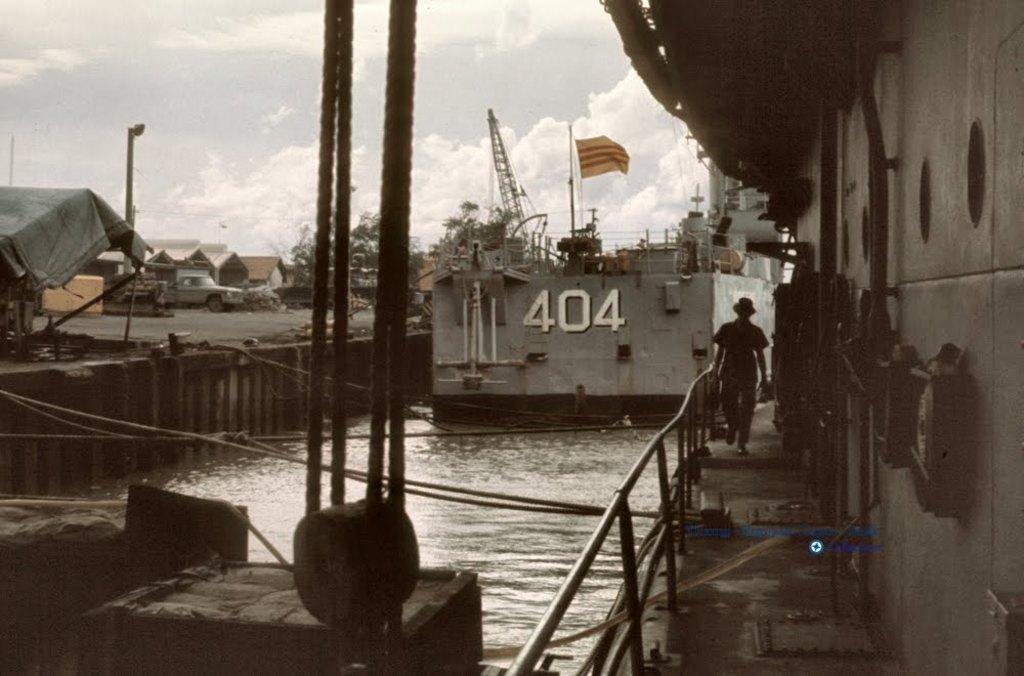What is the primary element visible in the image? There is water in the image. Can you describe the person in the image? There is a person in the image. What type of vehicle is present in the image? There is a vehicle in the image. What is the flag attached to in the image? The flag is attached to poles in the image. What type of vegetation is visible in the image? There are trees in the image. What is the large object floating on the water in the image? There is a ship in the image. What can be seen in the background of the image? The sky is visible in the background of the image. What arithmetic problem is the person solving in the image? There is no indication in the image that the person is solving an arithmetic problem. What advice does the mom give to the person in the image? There is no mom present in the image, so it's not possible to determine any advice given. 